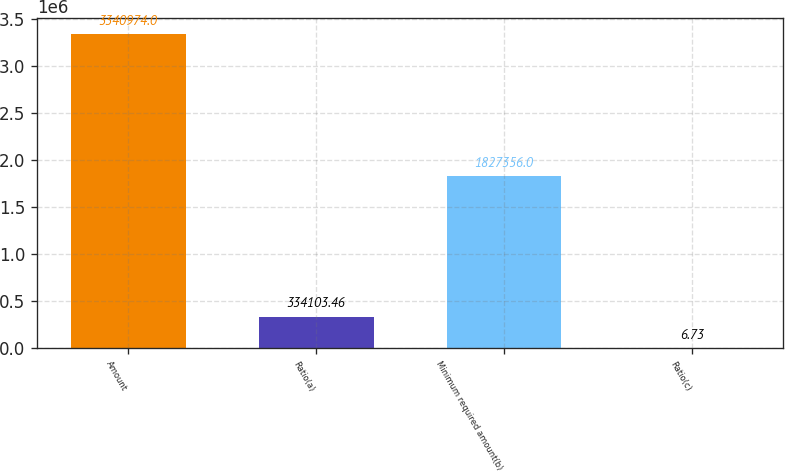<chart> <loc_0><loc_0><loc_500><loc_500><bar_chart><fcel>Amount<fcel>Ratio(a)<fcel>Minimum required amount(b)<fcel>Ratio(c)<nl><fcel>3.34097e+06<fcel>334103<fcel>1.82736e+06<fcel>6.73<nl></chart> 